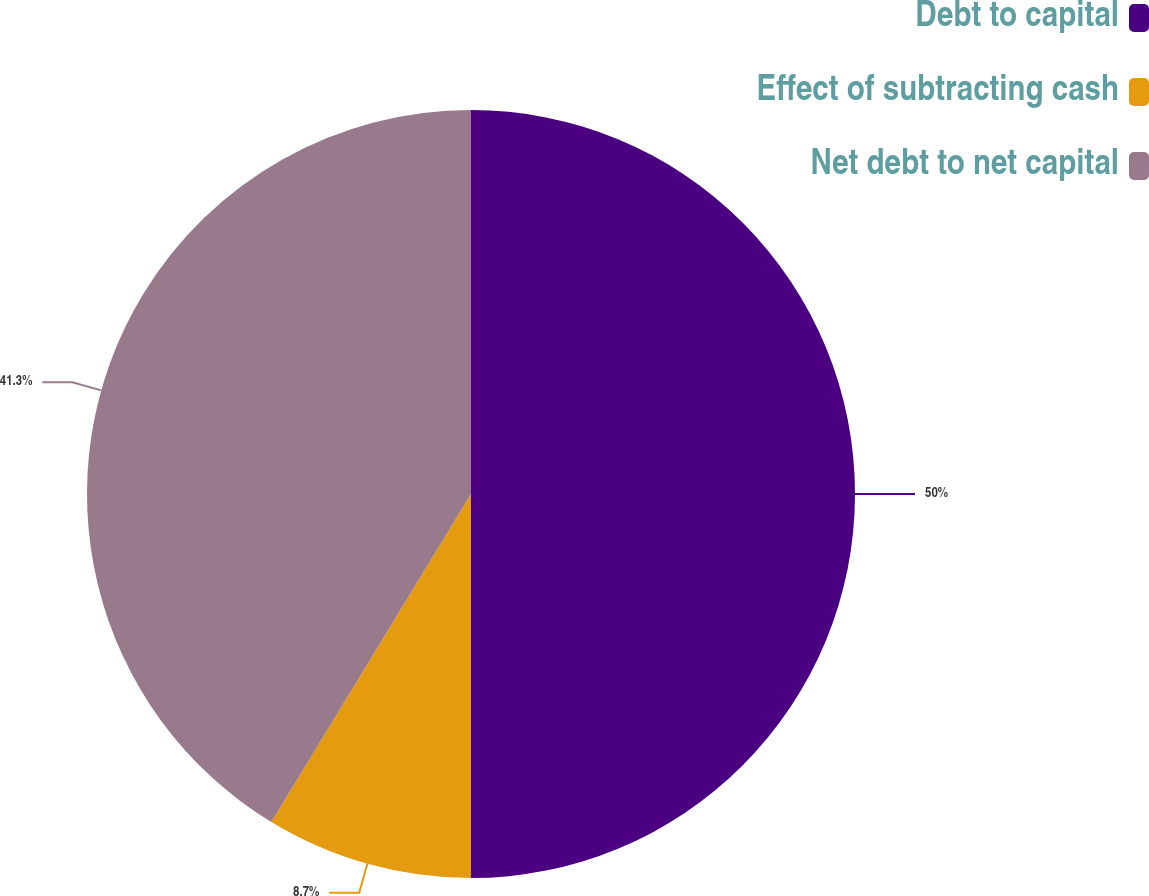Convert chart to OTSL. <chart><loc_0><loc_0><loc_500><loc_500><pie_chart><fcel>Debt to capital<fcel>Effect of subtracting cash<fcel>Net debt to net capital<nl><fcel>50.0%<fcel>8.7%<fcel>41.3%<nl></chart> 